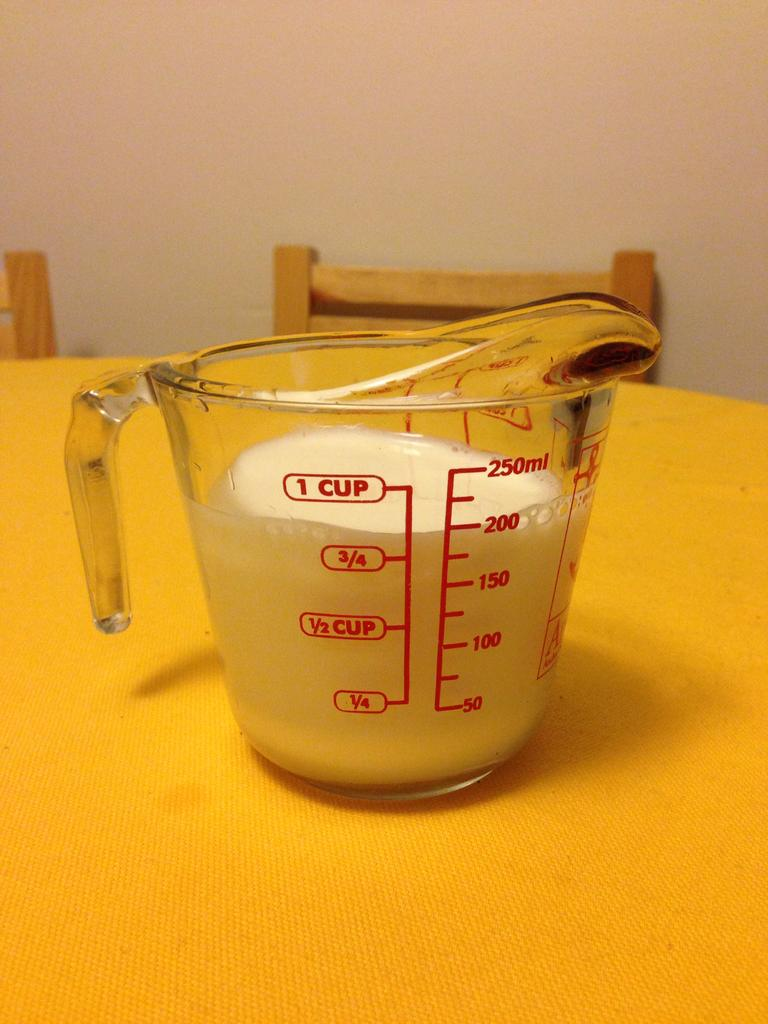<image>
Offer a succinct explanation of the picture presented. A clear glass measuring cup has 200 ml of liquid in it. 